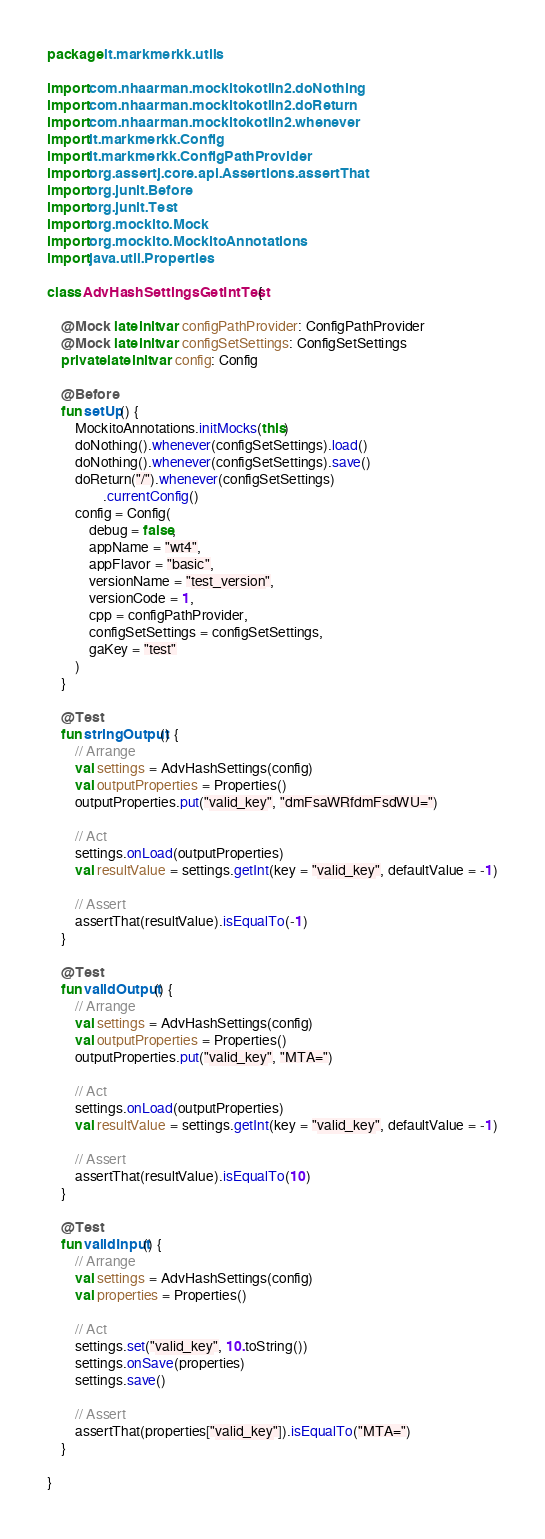Convert code to text. <code><loc_0><loc_0><loc_500><loc_500><_Kotlin_>package lt.markmerkk.utils

import com.nhaarman.mockitokotlin2.doNothing
import com.nhaarman.mockitokotlin2.doReturn
import com.nhaarman.mockitokotlin2.whenever
import lt.markmerkk.Config
import lt.markmerkk.ConfigPathProvider
import org.assertj.core.api.Assertions.assertThat
import org.junit.Before
import org.junit.Test
import org.mockito.Mock
import org.mockito.MockitoAnnotations
import java.util.Properties

class AdvHashSettingsGetIntTest {

    @Mock lateinit var configPathProvider: ConfigPathProvider
    @Mock lateinit var configSetSettings: ConfigSetSettings
    private lateinit var config: Config

    @Before
    fun setUp() {
        MockitoAnnotations.initMocks(this)
        doNothing().whenever(configSetSettings).load()
        doNothing().whenever(configSetSettings).save()
        doReturn("/").whenever(configSetSettings)
                .currentConfig()
        config = Config(
            debug = false,
            appName = "wt4",
            appFlavor = "basic",
            versionName = "test_version",
            versionCode = 1,
            cpp = configPathProvider,
            configSetSettings = configSetSettings,
            gaKey = "test"
        )
    }

    @Test
    fun stringOutput() {
        // Arrange
        val settings = AdvHashSettings(config)
        val outputProperties = Properties()
        outputProperties.put("valid_key", "dmFsaWRfdmFsdWU=")

        // Act
        settings.onLoad(outputProperties)
        val resultValue = settings.getInt(key = "valid_key", defaultValue = -1)

        // Assert
        assertThat(resultValue).isEqualTo(-1)
    }

    @Test
    fun validOutput() {
        // Arrange
        val settings = AdvHashSettings(config)
        val outputProperties = Properties()
        outputProperties.put("valid_key", "MTA=")

        // Act
        settings.onLoad(outputProperties)
        val resultValue = settings.getInt(key = "valid_key", defaultValue = -1)

        // Assert
        assertThat(resultValue).isEqualTo(10)
    }

    @Test
    fun validInput() {
        // Arrange
        val settings = AdvHashSettings(config)
        val properties = Properties()

        // Act
        settings.set("valid_key", 10.toString())
        settings.onSave(properties)
        settings.save()

        // Assert
        assertThat(properties["valid_key"]).isEqualTo("MTA=")
    }

}</code> 